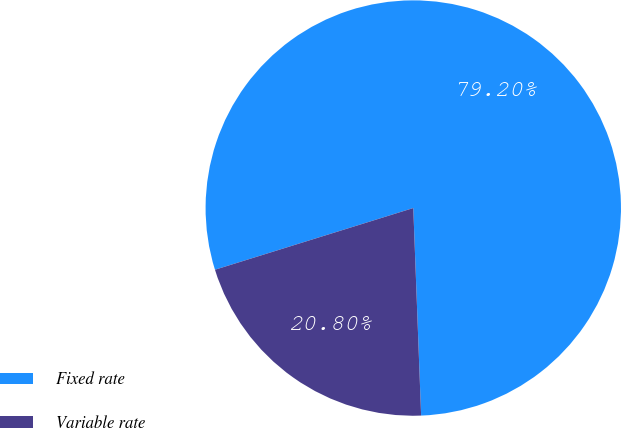Convert chart. <chart><loc_0><loc_0><loc_500><loc_500><pie_chart><fcel>Fixed rate<fcel>Variable rate<nl><fcel>79.2%<fcel>20.8%<nl></chart> 